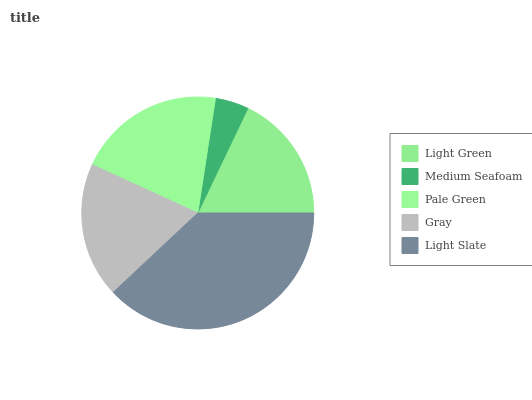Is Medium Seafoam the minimum?
Answer yes or no. Yes. Is Light Slate the maximum?
Answer yes or no. Yes. Is Pale Green the minimum?
Answer yes or no. No. Is Pale Green the maximum?
Answer yes or no. No. Is Pale Green greater than Medium Seafoam?
Answer yes or no. Yes. Is Medium Seafoam less than Pale Green?
Answer yes or no. Yes. Is Medium Seafoam greater than Pale Green?
Answer yes or no. No. Is Pale Green less than Medium Seafoam?
Answer yes or no. No. Is Gray the high median?
Answer yes or no. Yes. Is Gray the low median?
Answer yes or no. Yes. Is Medium Seafoam the high median?
Answer yes or no. No. Is Pale Green the low median?
Answer yes or no. No. 